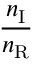<formula> <loc_0><loc_0><loc_500><loc_500>\frac { n _ { I } } { n _ { R } }</formula> 